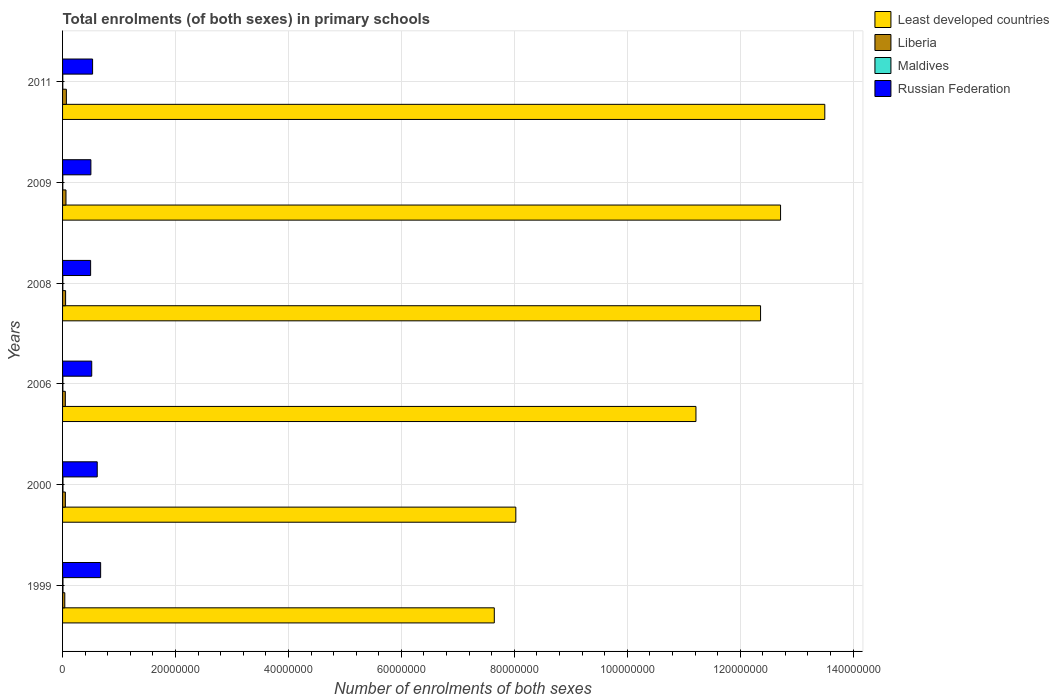How many groups of bars are there?
Your answer should be compact. 6. How many bars are there on the 4th tick from the bottom?
Your response must be concise. 4. What is the label of the 4th group of bars from the top?
Your response must be concise. 2006. What is the number of enrolments in primary schools in Russian Federation in 2000?
Provide a succinct answer. 6.14e+06. Across all years, what is the maximum number of enrolments in primary schools in Liberia?
Offer a terse response. 6.75e+05. Across all years, what is the minimum number of enrolments in primary schools in Liberia?
Your response must be concise. 3.96e+05. In which year was the number of enrolments in primary schools in Maldives minimum?
Offer a terse response. 2011. What is the total number of enrolments in primary schools in Liberia in the graph?
Give a very brief answer. 3.20e+06. What is the difference between the number of enrolments in primary schools in Least developed countries in 2000 and that in 2006?
Your answer should be compact. -3.19e+07. What is the difference between the number of enrolments in primary schools in Liberia in 2009 and the number of enrolments in primary schools in Least developed countries in 2000?
Offer a terse response. -7.97e+07. What is the average number of enrolments in primary schools in Russian Federation per year?
Keep it short and to the point. 5.56e+06. In the year 2008, what is the difference between the number of enrolments in primary schools in Maldives and number of enrolments in primary schools in Russian Federation?
Give a very brief answer. -4.92e+06. What is the ratio of the number of enrolments in primary schools in Liberia in 2000 to that in 2011?
Your answer should be very brief. 0.74. Is the difference between the number of enrolments in primary schools in Maldives in 2006 and 2011 greater than the difference between the number of enrolments in primary schools in Russian Federation in 2006 and 2011?
Provide a short and direct response. Yes. What is the difference between the highest and the second highest number of enrolments in primary schools in Russian Federation?
Your response must be concise. 6.04e+05. What is the difference between the highest and the lowest number of enrolments in primary schools in Least developed countries?
Give a very brief answer. 5.85e+07. Is the sum of the number of enrolments in primary schools in Liberia in 2000 and 2009 greater than the maximum number of enrolments in primary schools in Least developed countries across all years?
Your answer should be compact. No. Is it the case that in every year, the sum of the number of enrolments in primary schools in Maldives and number of enrolments in primary schools in Russian Federation is greater than the sum of number of enrolments in primary schools in Liberia and number of enrolments in primary schools in Least developed countries?
Make the answer very short. No. What does the 1st bar from the top in 2000 represents?
Provide a succinct answer. Russian Federation. What does the 4th bar from the bottom in 1999 represents?
Your answer should be compact. Russian Federation. Is it the case that in every year, the sum of the number of enrolments in primary schools in Least developed countries and number of enrolments in primary schools in Liberia is greater than the number of enrolments in primary schools in Russian Federation?
Offer a very short reply. Yes. How many bars are there?
Offer a very short reply. 24. How many years are there in the graph?
Make the answer very short. 6. Does the graph contain any zero values?
Make the answer very short. No. Where does the legend appear in the graph?
Provide a succinct answer. Top right. How are the legend labels stacked?
Provide a short and direct response. Vertical. What is the title of the graph?
Your response must be concise. Total enrolments (of both sexes) in primary schools. Does "Samoa" appear as one of the legend labels in the graph?
Offer a very short reply. No. What is the label or title of the X-axis?
Provide a short and direct response. Number of enrolments of both sexes. What is the label or title of the Y-axis?
Provide a short and direct response. Years. What is the Number of enrolments of both sexes in Least developed countries in 1999?
Offer a very short reply. 7.65e+07. What is the Number of enrolments of both sexes of Liberia in 1999?
Your answer should be compact. 3.96e+05. What is the Number of enrolments of both sexes in Maldives in 1999?
Provide a succinct answer. 7.40e+04. What is the Number of enrolments of both sexes of Russian Federation in 1999?
Your answer should be very brief. 6.74e+06. What is the Number of enrolments of both sexes in Least developed countries in 2000?
Make the answer very short. 8.03e+07. What is the Number of enrolments of both sexes of Liberia in 2000?
Provide a succinct answer. 4.96e+05. What is the Number of enrolments of both sexes of Maldives in 2000?
Your answer should be very brief. 7.35e+04. What is the Number of enrolments of both sexes of Russian Federation in 2000?
Give a very brief answer. 6.14e+06. What is the Number of enrolments of both sexes in Least developed countries in 2006?
Make the answer very short. 1.12e+08. What is the Number of enrolments of both sexes in Liberia in 2006?
Your response must be concise. 4.88e+05. What is the Number of enrolments of both sexes in Maldives in 2006?
Your response must be concise. 5.48e+04. What is the Number of enrolments of both sexes of Russian Federation in 2006?
Give a very brief answer. 5.16e+06. What is the Number of enrolments of both sexes of Least developed countries in 2008?
Offer a very short reply. 1.24e+08. What is the Number of enrolments of both sexes in Liberia in 2008?
Your answer should be very brief. 5.40e+05. What is the Number of enrolments of both sexes of Maldives in 2008?
Ensure brevity in your answer.  4.71e+04. What is the Number of enrolments of both sexes of Russian Federation in 2008?
Make the answer very short. 4.97e+06. What is the Number of enrolments of both sexes of Least developed countries in 2009?
Provide a short and direct response. 1.27e+08. What is the Number of enrolments of both sexes of Liberia in 2009?
Your answer should be compact. 6.05e+05. What is the Number of enrolments of both sexes of Maldives in 2009?
Your answer should be compact. 4.47e+04. What is the Number of enrolments of both sexes in Russian Federation in 2009?
Provide a succinct answer. 5.02e+06. What is the Number of enrolments of both sexes of Least developed countries in 2011?
Provide a succinct answer. 1.35e+08. What is the Number of enrolments of both sexes of Liberia in 2011?
Provide a short and direct response. 6.75e+05. What is the Number of enrolments of both sexes in Maldives in 2011?
Your answer should be very brief. 4.02e+04. What is the Number of enrolments of both sexes of Russian Federation in 2011?
Provide a short and direct response. 5.32e+06. Across all years, what is the maximum Number of enrolments of both sexes in Least developed countries?
Keep it short and to the point. 1.35e+08. Across all years, what is the maximum Number of enrolments of both sexes of Liberia?
Make the answer very short. 6.75e+05. Across all years, what is the maximum Number of enrolments of both sexes in Maldives?
Offer a very short reply. 7.40e+04. Across all years, what is the maximum Number of enrolments of both sexes in Russian Federation?
Provide a succinct answer. 6.74e+06. Across all years, what is the minimum Number of enrolments of both sexes in Least developed countries?
Your response must be concise. 7.65e+07. Across all years, what is the minimum Number of enrolments of both sexes of Liberia?
Keep it short and to the point. 3.96e+05. Across all years, what is the minimum Number of enrolments of both sexes of Maldives?
Offer a very short reply. 4.02e+04. Across all years, what is the minimum Number of enrolments of both sexes of Russian Federation?
Offer a terse response. 4.97e+06. What is the total Number of enrolments of both sexes of Least developed countries in the graph?
Offer a very short reply. 6.55e+08. What is the total Number of enrolments of both sexes in Liberia in the graph?
Offer a very short reply. 3.20e+06. What is the total Number of enrolments of both sexes of Maldives in the graph?
Offer a terse response. 3.34e+05. What is the total Number of enrolments of both sexes of Russian Federation in the graph?
Provide a short and direct response. 3.33e+07. What is the difference between the Number of enrolments of both sexes of Least developed countries in 1999 and that in 2000?
Provide a short and direct response. -3.81e+06. What is the difference between the Number of enrolments of both sexes in Liberia in 1999 and that in 2000?
Your response must be concise. -1.01e+05. What is the difference between the Number of enrolments of both sexes in Maldives in 1999 and that in 2000?
Your answer should be compact. 528. What is the difference between the Number of enrolments of both sexes in Russian Federation in 1999 and that in 2000?
Keep it short and to the point. 6.04e+05. What is the difference between the Number of enrolments of both sexes of Least developed countries in 1999 and that in 2006?
Provide a succinct answer. -3.57e+07. What is the difference between the Number of enrolments of both sexes of Liberia in 1999 and that in 2006?
Your response must be concise. -9.28e+04. What is the difference between the Number of enrolments of both sexes of Maldives in 1999 and that in 2006?
Your response must be concise. 1.93e+04. What is the difference between the Number of enrolments of both sexes of Russian Federation in 1999 and that in 2006?
Your response must be concise. 1.58e+06. What is the difference between the Number of enrolments of both sexes of Least developed countries in 1999 and that in 2008?
Your response must be concise. -4.72e+07. What is the difference between the Number of enrolments of both sexes of Liberia in 1999 and that in 2008?
Your answer should be compact. -1.44e+05. What is the difference between the Number of enrolments of both sexes of Maldives in 1999 and that in 2008?
Keep it short and to the point. 2.70e+04. What is the difference between the Number of enrolments of both sexes of Russian Federation in 1999 and that in 2008?
Provide a succinct answer. 1.77e+06. What is the difference between the Number of enrolments of both sexes in Least developed countries in 1999 and that in 2009?
Your answer should be compact. -5.07e+07. What is the difference between the Number of enrolments of both sexes in Liberia in 1999 and that in 2009?
Offer a very short reply. -2.10e+05. What is the difference between the Number of enrolments of both sexes in Maldives in 1999 and that in 2009?
Your answer should be very brief. 2.94e+04. What is the difference between the Number of enrolments of both sexes of Russian Federation in 1999 and that in 2009?
Your response must be concise. 1.73e+06. What is the difference between the Number of enrolments of both sexes in Least developed countries in 1999 and that in 2011?
Offer a very short reply. -5.85e+07. What is the difference between the Number of enrolments of both sexes in Liberia in 1999 and that in 2011?
Offer a very short reply. -2.79e+05. What is the difference between the Number of enrolments of both sexes of Maldives in 1999 and that in 2011?
Ensure brevity in your answer.  3.38e+04. What is the difference between the Number of enrolments of both sexes of Russian Federation in 1999 and that in 2011?
Offer a very short reply. 1.42e+06. What is the difference between the Number of enrolments of both sexes of Least developed countries in 2000 and that in 2006?
Your response must be concise. -3.19e+07. What is the difference between the Number of enrolments of both sexes of Liberia in 2000 and that in 2006?
Your answer should be very brief. 7815. What is the difference between the Number of enrolments of both sexes in Maldives in 2000 and that in 2006?
Give a very brief answer. 1.88e+04. What is the difference between the Number of enrolments of both sexes in Russian Federation in 2000 and that in 2006?
Your response must be concise. 9.74e+05. What is the difference between the Number of enrolments of both sexes in Least developed countries in 2000 and that in 2008?
Your answer should be compact. -4.33e+07. What is the difference between the Number of enrolments of both sexes in Liberia in 2000 and that in 2008?
Your answer should be very brief. -4.36e+04. What is the difference between the Number of enrolments of both sexes of Maldives in 2000 and that in 2008?
Offer a very short reply. 2.64e+04. What is the difference between the Number of enrolments of both sexes in Russian Federation in 2000 and that in 2008?
Provide a short and direct response. 1.17e+06. What is the difference between the Number of enrolments of both sexes in Least developed countries in 2000 and that in 2009?
Ensure brevity in your answer.  -4.69e+07. What is the difference between the Number of enrolments of both sexes in Liberia in 2000 and that in 2009?
Keep it short and to the point. -1.09e+05. What is the difference between the Number of enrolments of both sexes in Maldives in 2000 and that in 2009?
Give a very brief answer. 2.88e+04. What is the difference between the Number of enrolments of both sexes of Russian Federation in 2000 and that in 2009?
Give a very brief answer. 1.12e+06. What is the difference between the Number of enrolments of both sexes in Least developed countries in 2000 and that in 2011?
Ensure brevity in your answer.  -5.47e+07. What is the difference between the Number of enrolments of both sexes in Liberia in 2000 and that in 2011?
Provide a succinct answer. -1.78e+05. What is the difference between the Number of enrolments of both sexes of Maldives in 2000 and that in 2011?
Ensure brevity in your answer.  3.33e+04. What is the difference between the Number of enrolments of both sexes in Russian Federation in 2000 and that in 2011?
Offer a very short reply. 8.20e+05. What is the difference between the Number of enrolments of both sexes of Least developed countries in 2006 and that in 2008?
Your answer should be compact. -1.14e+07. What is the difference between the Number of enrolments of both sexes in Liberia in 2006 and that in 2008?
Offer a terse response. -5.14e+04. What is the difference between the Number of enrolments of both sexes of Maldives in 2006 and that in 2008?
Offer a very short reply. 7688. What is the difference between the Number of enrolments of both sexes of Russian Federation in 2006 and that in 2008?
Provide a short and direct response. 1.96e+05. What is the difference between the Number of enrolments of both sexes in Least developed countries in 2006 and that in 2009?
Provide a short and direct response. -1.50e+07. What is the difference between the Number of enrolments of both sexes in Liberia in 2006 and that in 2009?
Provide a short and direct response. -1.17e+05. What is the difference between the Number of enrolments of both sexes in Maldives in 2006 and that in 2009?
Offer a terse response. 1.01e+04. What is the difference between the Number of enrolments of both sexes of Russian Federation in 2006 and that in 2009?
Keep it short and to the point. 1.49e+05. What is the difference between the Number of enrolments of both sexes of Least developed countries in 2006 and that in 2011?
Your answer should be very brief. -2.28e+07. What is the difference between the Number of enrolments of both sexes in Liberia in 2006 and that in 2011?
Your answer should be compact. -1.86e+05. What is the difference between the Number of enrolments of both sexes in Maldives in 2006 and that in 2011?
Make the answer very short. 1.46e+04. What is the difference between the Number of enrolments of both sexes in Russian Federation in 2006 and that in 2011?
Make the answer very short. -1.54e+05. What is the difference between the Number of enrolments of both sexes of Least developed countries in 2008 and that in 2009?
Make the answer very short. -3.54e+06. What is the difference between the Number of enrolments of both sexes in Liberia in 2008 and that in 2009?
Provide a succinct answer. -6.53e+04. What is the difference between the Number of enrolments of both sexes in Maldives in 2008 and that in 2009?
Offer a terse response. 2407. What is the difference between the Number of enrolments of both sexes of Russian Federation in 2008 and that in 2009?
Offer a very short reply. -4.66e+04. What is the difference between the Number of enrolments of both sexes of Least developed countries in 2008 and that in 2011?
Offer a very short reply. -1.14e+07. What is the difference between the Number of enrolments of both sexes of Liberia in 2008 and that in 2011?
Your answer should be compact. -1.35e+05. What is the difference between the Number of enrolments of both sexes in Maldives in 2008 and that in 2011?
Provide a succinct answer. 6881. What is the difference between the Number of enrolments of both sexes of Russian Federation in 2008 and that in 2011?
Offer a terse response. -3.50e+05. What is the difference between the Number of enrolments of both sexes of Least developed countries in 2009 and that in 2011?
Keep it short and to the point. -7.83e+06. What is the difference between the Number of enrolments of both sexes in Liberia in 2009 and that in 2011?
Give a very brief answer. -6.93e+04. What is the difference between the Number of enrolments of both sexes in Maldives in 2009 and that in 2011?
Give a very brief answer. 4474. What is the difference between the Number of enrolments of both sexes in Russian Federation in 2009 and that in 2011?
Your response must be concise. -3.03e+05. What is the difference between the Number of enrolments of both sexes in Least developed countries in 1999 and the Number of enrolments of both sexes in Liberia in 2000?
Offer a very short reply. 7.60e+07. What is the difference between the Number of enrolments of both sexes in Least developed countries in 1999 and the Number of enrolments of both sexes in Maldives in 2000?
Keep it short and to the point. 7.64e+07. What is the difference between the Number of enrolments of both sexes of Least developed countries in 1999 and the Number of enrolments of both sexes of Russian Federation in 2000?
Offer a terse response. 7.03e+07. What is the difference between the Number of enrolments of both sexes in Liberia in 1999 and the Number of enrolments of both sexes in Maldives in 2000?
Ensure brevity in your answer.  3.22e+05. What is the difference between the Number of enrolments of both sexes in Liberia in 1999 and the Number of enrolments of both sexes in Russian Federation in 2000?
Offer a very short reply. -5.74e+06. What is the difference between the Number of enrolments of both sexes of Maldives in 1999 and the Number of enrolments of both sexes of Russian Federation in 2000?
Offer a terse response. -6.06e+06. What is the difference between the Number of enrolments of both sexes in Least developed countries in 1999 and the Number of enrolments of both sexes in Liberia in 2006?
Provide a succinct answer. 7.60e+07. What is the difference between the Number of enrolments of both sexes of Least developed countries in 1999 and the Number of enrolments of both sexes of Maldives in 2006?
Provide a succinct answer. 7.64e+07. What is the difference between the Number of enrolments of both sexes in Least developed countries in 1999 and the Number of enrolments of both sexes in Russian Federation in 2006?
Provide a short and direct response. 7.13e+07. What is the difference between the Number of enrolments of both sexes in Liberia in 1999 and the Number of enrolments of both sexes in Maldives in 2006?
Give a very brief answer. 3.41e+05. What is the difference between the Number of enrolments of both sexes of Liberia in 1999 and the Number of enrolments of both sexes of Russian Federation in 2006?
Make the answer very short. -4.77e+06. What is the difference between the Number of enrolments of both sexes of Maldives in 1999 and the Number of enrolments of both sexes of Russian Federation in 2006?
Your answer should be compact. -5.09e+06. What is the difference between the Number of enrolments of both sexes in Least developed countries in 1999 and the Number of enrolments of both sexes in Liberia in 2008?
Offer a terse response. 7.59e+07. What is the difference between the Number of enrolments of both sexes in Least developed countries in 1999 and the Number of enrolments of both sexes in Maldives in 2008?
Your response must be concise. 7.64e+07. What is the difference between the Number of enrolments of both sexes of Least developed countries in 1999 and the Number of enrolments of both sexes of Russian Federation in 2008?
Offer a very short reply. 7.15e+07. What is the difference between the Number of enrolments of both sexes of Liberia in 1999 and the Number of enrolments of both sexes of Maldives in 2008?
Offer a very short reply. 3.49e+05. What is the difference between the Number of enrolments of both sexes of Liberia in 1999 and the Number of enrolments of both sexes of Russian Federation in 2008?
Provide a short and direct response. -4.57e+06. What is the difference between the Number of enrolments of both sexes in Maldives in 1999 and the Number of enrolments of both sexes in Russian Federation in 2008?
Your answer should be compact. -4.89e+06. What is the difference between the Number of enrolments of both sexes in Least developed countries in 1999 and the Number of enrolments of both sexes in Liberia in 2009?
Ensure brevity in your answer.  7.58e+07. What is the difference between the Number of enrolments of both sexes of Least developed countries in 1999 and the Number of enrolments of both sexes of Maldives in 2009?
Provide a short and direct response. 7.64e+07. What is the difference between the Number of enrolments of both sexes of Least developed countries in 1999 and the Number of enrolments of both sexes of Russian Federation in 2009?
Offer a terse response. 7.14e+07. What is the difference between the Number of enrolments of both sexes in Liberia in 1999 and the Number of enrolments of both sexes in Maldives in 2009?
Provide a succinct answer. 3.51e+05. What is the difference between the Number of enrolments of both sexes of Liberia in 1999 and the Number of enrolments of both sexes of Russian Federation in 2009?
Provide a short and direct response. -4.62e+06. What is the difference between the Number of enrolments of both sexes of Maldives in 1999 and the Number of enrolments of both sexes of Russian Federation in 2009?
Ensure brevity in your answer.  -4.94e+06. What is the difference between the Number of enrolments of both sexes of Least developed countries in 1999 and the Number of enrolments of both sexes of Liberia in 2011?
Provide a short and direct response. 7.58e+07. What is the difference between the Number of enrolments of both sexes of Least developed countries in 1999 and the Number of enrolments of both sexes of Maldives in 2011?
Offer a very short reply. 7.64e+07. What is the difference between the Number of enrolments of both sexes of Least developed countries in 1999 and the Number of enrolments of both sexes of Russian Federation in 2011?
Give a very brief answer. 7.11e+07. What is the difference between the Number of enrolments of both sexes of Liberia in 1999 and the Number of enrolments of both sexes of Maldives in 2011?
Make the answer very short. 3.55e+05. What is the difference between the Number of enrolments of both sexes in Liberia in 1999 and the Number of enrolments of both sexes in Russian Federation in 2011?
Your answer should be compact. -4.92e+06. What is the difference between the Number of enrolments of both sexes of Maldives in 1999 and the Number of enrolments of both sexes of Russian Federation in 2011?
Keep it short and to the point. -5.24e+06. What is the difference between the Number of enrolments of both sexes in Least developed countries in 2000 and the Number of enrolments of both sexes in Liberia in 2006?
Provide a short and direct response. 7.98e+07. What is the difference between the Number of enrolments of both sexes of Least developed countries in 2000 and the Number of enrolments of both sexes of Maldives in 2006?
Give a very brief answer. 8.02e+07. What is the difference between the Number of enrolments of both sexes in Least developed countries in 2000 and the Number of enrolments of both sexes in Russian Federation in 2006?
Make the answer very short. 7.51e+07. What is the difference between the Number of enrolments of both sexes of Liberia in 2000 and the Number of enrolments of both sexes of Maldives in 2006?
Provide a succinct answer. 4.41e+05. What is the difference between the Number of enrolments of both sexes of Liberia in 2000 and the Number of enrolments of both sexes of Russian Federation in 2006?
Offer a very short reply. -4.67e+06. What is the difference between the Number of enrolments of both sexes of Maldives in 2000 and the Number of enrolments of both sexes of Russian Federation in 2006?
Provide a short and direct response. -5.09e+06. What is the difference between the Number of enrolments of both sexes of Least developed countries in 2000 and the Number of enrolments of both sexes of Liberia in 2008?
Keep it short and to the point. 7.97e+07. What is the difference between the Number of enrolments of both sexes in Least developed countries in 2000 and the Number of enrolments of both sexes in Maldives in 2008?
Your answer should be compact. 8.02e+07. What is the difference between the Number of enrolments of both sexes of Least developed countries in 2000 and the Number of enrolments of both sexes of Russian Federation in 2008?
Offer a terse response. 7.53e+07. What is the difference between the Number of enrolments of both sexes of Liberia in 2000 and the Number of enrolments of both sexes of Maldives in 2008?
Ensure brevity in your answer.  4.49e+05. What is the difference between the Number of enrolments of both sexes in Liberia in 2000 and the Number of enrolments of both sexes in Russian Federation in 2008?
Your response must be concise. -4.47e+06. What is the difference between the Number of enrolments of both sexes in Maldives in 2000 and the Number of enrolments of both sexes in Russian Federation in 2008?
Make the answer very short. -4.90e+06. What is the difference between the Number of enrolments of both sexes in Least developed countries in 2000 and the Number of enrolments of both sexes in Liberia in 2009?
Make the answer very short. 7.97e+07. What is the difference between the Number of enrolments of both sexes of Least developed countries in 2000 and the Number of enrolments of both sexes of Maldives in 2009?
Ensure brevity in your answer.  8.02e+07. What is the difference between the Number of enrolments of both sexes in Least developed countries in 2000 and the Number of enrolments of both sexes in Russian Federation in 2009?
Offer a very short reply. 7.52e+07. What is the difference between the Number of enrolments of both sexes in Liberia in 2000 and the Number of enrolments of both sexes in Maldives in 2009?
Keep it short and to the point. 4.52e+05. What is the difference between the Number of enrolments of both sexes of Liberia in 2000 and the Number of enrolments of both sexes of Russian Federation in 2009?
Provide a succinct answer. -4.52e+06. What is the difference between the Number of enrolments of both sexes of Maldives in 2000 and the Number of enrolments of both sexes of Russian Federation in 2009?
Your answer should be very brief. -4.94e+06. What is the difference between the Number of enrolments of both sexes in Least developed countries in 2000 and the Number of enrolments of both sexes in Liberia in 2011?
Provide a short and direct response. 7.96e+07. What is the difference between the Number of enrolments of both sexes of Least developed countries in 2000 and the Number of enrolments of both sexes of Maldives in 2011?
Make the answer very short. 8.02e+07. What is the difference between the Number of enrolments of both sexes of Least developed countries in 2000 and the Number of enrolments of both sexes of Russian Federation in 2011?
Make the answer very short. 7.49e+07. What is the difference between the Number of enrolments of both sexes in Liberia in 2000 and the Number of enrolments of both sexes in Maldives in 2011?
Give a very brief answer. 4.56e+05. What is the difference between the Number of enrolments of both sexes in Liberia in 2000 and the Number of enrolments of both sexes in Russian Federation in 2011?
Your answer should be very brief. -4.82e+06. What is the difference between the Number of enrolments of both sexes of Maldives in 2000 and the Number of enrolments of both sexes of Russian Federation in 2011?
Offer a very short reply. -5.24e+06. What is the difference between the Number of enrolments of both sexes of Least developed countries in 2006 and the Number of enrolments of both sexes of Liberia in 2008?
Your response must be concise. 1.12e+08. What is the difference between the Number of enrolments of both sexes of Least developed countries in 2006 and the Number of enrolments of both sexes of Maldives in 2008?
Keep it short and to the point. 1.12e+08. What is the difference between the Number of enrolments of both sexes of Least developed countries in 2006 and the Number of enrolments of both sexes of Russian Federation in 2008?
Give a very brief answer. 1.07e+08. What is the difference between the Number of enrolments of both sexes of Liberia in 2006 and the Number of enrolments of both sexes of Maldives in 2008?
Your answer should be compact. 4.41e+05. What is the difference between the Number of enrolments of both sexes of Liberia in 2006 and the Number of enrolments of both sexes of Russian Federation in 2008?
Your answer should be very brief. -4.48e+06. What is the difference between the Number of enrolments of both sexes in Maldives in 2006 and the Number of enrolments of both sexes in Russian Federation in 2008?
Ensure brevity in your answer.  -4.91e+06. What is the difference between the Number of enrolments of both sexes in Least developed countries in 2006 and the Number of enrolments of both sexes in Liberia in 2009?
Your answer should be very brief. 1.12e+08. What is the difference between the Number of enrolments of both sexes of Least developed countries in 2006 and the Number of enrolments of both sexes of Maldives in 2009?
Give a very brief answer. 1.12e+08. What is the difference between the Number of enrolments of both sexes in Least developed countries in 2006 and the Number of enrolments of both sexes in Russian Federation in 2009?
Your answer should be very brief. 1.07e+08. What is the difference between the Number of enrolments of both sexes in Liberia in 2006 and the Number of enrolments of both sexes in Maldives in 2009?
Offer a terse response. 4.44e+05. What is the difference between the Number of enrolments of both sexes of Liberia in 2006 and the Number of enrolments of both sexes of Russian Federation in 2009?
Provide a succinct answer. -4.53e+06. What is the difference between the Number of enrolments of both sexes of Maldives in 2006 and the Number of enrolments of both sexes of Russian Federation in 2009?
Give a very brief answer. -4.96e+06. What is the difference between the Number of enrolments of both sexes of Least developed countries in 2006 and the Number of enrolments of both sexes of Liberia in 2011?
Offer a very short reply. 1.11e+08. What is the difference between the Number of enrolments of both sexes in Least developed countries in 2006 and the Number of enrolments of both sexes in Maldives in 2011?
Give a very brief answer. 1.12e+08. What is the difference between the Number of enrolments of both sexes in Least developed countries in 2006 and the Number of enrolments of both sexes in Russian Federation in 2011?
Make the answer very short. 1.07e+08. What is the difference between the Number of enrolments of both sexes in Liberia in 2006 and the Number of enrolments of both sexes in Maldives in 2011?
Make the answer very short. 4.48e+05. What is the difference between the Number of enrolments of both sexes in Liberia in 2006 and the Number of enrolments of both sexes in Russian Federation in 2011?
Make the answer very short. -4.83e+06. What is the difference between the Number of enrolments of both sexes of Maldives in 2006 and the Number of enrolments of both sexes of Russian Federation in 2011?
Provide a short and direct response. -5.26e+06. What is the difference between the Number of enrolments of both sexes of Least developed countries in 2008 and the Number of enrolments of both sexes of Liberia in 2009?
Ensure brevity in your answer.  1.23e+08. What is the difference between the Number of enrolments of both sexes of Least developed countries in 2008 and the Number of enrolments of both sexes of Maldives in 2009?
Keep it short and to the point. 1.24e+08. What is the difference between the Number of enrolments of both sexes of Least developed countries in 2008 and the Number of enrolments of both sexes of Russian Federation in 2009?
Offer a very short reply. 1.19e+08. What is the difference between the Number of enrolments of both sexes in Liberia in 2008 and the Number of enrolments of both sexes in Maldives in 2009?
Keep it short and to the point. 4.95e+05. What is the difference between the Number of enrolments of both sexes of Liberia in 2008 and the Number of enrolments of both sexes of Russian Federation in 2009?
Ensure brevity in your answer.  -4.48e+06. What is the difference between the Number of enrolments of both sexes in Maldives in 2008 and the Number of enrolments of both sexes in Russian Federation in 2009?
Ensure brevity in your answer.  -4.97e+06. What is the difference between the Number of enrolments of both sexes in Least developed countries in 2008 and the Number of enrolments of both sexes in Liberia in 2011?
Provide a short and direct response. 1.23e+08. What is the difference between the Number of enrolments of both sexes in Least developed countries in 2008 and the Number of enrolments of both sexes in Maldives in 2011?
Provide a short and direct response. 1.24e+08. What is the difference between the Number of enrolments of both sexes of Least developed countries in 2008 and the Number of enrolments of both sexes of Russian Federation in 2011?
Your answer should be very brief. 1.18e+08. What is the difference between the Number of enrolments of both sexes of Liberia in 2008 and the Number of enrolments of both sexes of Maldives in 2011?
Offer a very short reply. 5.00e+05. What is the difference between the Number of enrolments of both sexes of Liberia in 2008 and the Number of enrolments of both sexes of Russian Federation in 2011?
Provide a short and direct response. -4.78e+06. What is the difference between the Number of enrolments of both sexes of Maldives in 2008 and the Number of enrolments of both sexes of Russian Federation in 2011?
Provide a short and direct response. -5.27e+06. What is the difference between the Number of enrolments of both sexes in Least developed countries in 2009 and the Number of enrolments of both sexes in Liberia in 2011?
Provide a succinct answer. 1.26e+08. What is the difference between the Number of enrolments of both sexes of Least developed countries in 2009 and the Number of enrolments of both sexes of Maldives in 2011?
Your answer should be compact. 1.27e+08. What is the difference between the Number of enrolments of both sexes in Least developed countries in 2009 and the Number of enrolments of both sexes in Russian Federation in 2011?
Ensure brevity in your answer.  1.22e+08. What is the difference between the Number of enrolments of both sexes of Liberia in 2009 and the Number of enrolments of both sexes of Maldives in 2011?
Ensure brevity in your answer.  5.65e+05. What is the difference between the Number of enrolments of both sexes of Liberia in 2009 and the Number of enrolments of both sexes of Russian Federation in 2011?
Offer a very short reply. -4.71e+06. What is the difference between the Number of enrolments of both sexes of Maldives in 2009 and the Number of enrolments of both sexes of Russian Federation in 2011?
Provide a succinct answer. -5.27e+06. What is the average Number of enrolments of both sexes in Least developed countries per year?
Offer a terse response. 1.09e+08. What is the average Number of enrolments of both sexes in Liberia per year?
Provide a succinct answer. 5.33e+05. What is the average Number of enrolments of both sexes of Maldives per year?
Provide a short and direct response. 5.57e+04. What is the average Number of enrolments of both sexes of Russian Federation per year?
Keep it short and to the point. 5.56e+06. In the year 1999, what is the difference between the Number of enrolments of both sexes of Least developed countries and Number of enrolments of both sexes of Liberia?
Your answer should be compact. 7.61e+07. In the year 1999, what is the difference between the Number of enrolments of both sexes in Least developed countries and Number of enrolments of both sexes in Maldives?
Your response must be concise. 7.64e+07. In the year 1999, what is the difference between the Number of enrolments of both sexes of Least developed countries and Number of enrolments of both sexes of Russian Federation?
Your answer should be compact. 6.97e+07. In the year 1999, what is the difference between the Number of enrolments of both sexes in Liberia and Number of enrolments of both sexes in Maldives?
Give a very brief answer. 3.22e+05. In the year 1999, what is the difference between the Number of enrolments of both sexes in Liberia and Number of enrolments of both sexes in Russian Federation?
Offer a very short reply. -6.35e+06. In the year 1999, what is the difference between the Number of enrolments of both sexes of Maldives and Number of enrolments of both sexes of Russian Federation?
Give a very brief answer. -6.67e+06. In the year 2000, what is the difference between the Number of enrolments of both sexes in Least developed countries and Number of enrolments of both sexes in Liberia?
Offer a terse response. 7.98e+07. In the year 2000, what is the difference between the Number of enrolments of both sexes of Least developed countries and Number of enrolments of both sexes of Maldives?
Your answer should be compact. 8.02e+07. In the year 2000, what is the difference between the Number of enrolments of both sexes in Least developed countries and Number of enrolments of both sexes in Russian Federation?
Offer a very short reply. 7.41e+07. In the year 2000, what is the difference between the Number of enrolments of both sexes of Liberia and Number of enrolments of both sexes of Maldives?
Provide a succinct answer. 4.23e+05. In the year 2000, what is the difference between the Number of enrolments of both sexes in Liberia and Number of enrolments of both sexes in Russian Federation?
Provide a succinct answer. -5.64e+06. In the year 2000, what is the difference between the Number of enrolments of both sexes in Maldives and Number of enrolments of both sexes in Russian Federation?
Ensure brevity in your answer.  -6.06e+06. In the year 2006, what is the difference between the Number of enrolments of both sexes in Least developed countries and Number of enrolments of both sexes in Liberia?
Make the answer very short. 1.12e+08. In the year 2006, what is the difference between the Number of enrolments of both sexes of Least developed countries and Number of enrolments of both sexes of Maldives?
Provide a succinct answer. 1.12e+08. In the year 2006, what is the difference between the Number of enrolments of both sexes of Least developed countries and Number of enrolments of both sexes of Russian Federation?
Provide a short and direct response. 1.07e+08. In the year 2006, what is the difference between the Number of enrolments of both sexes in Liberia and Number of enrolments of both sexes in Maldives?
Provide a succinct answer. 4.34e+05. In the year 2006, what is the difference between the Number of enrolments of both sexes of Liberia and Number of enrolments of both sexes of Russian Federation?
Keep it short and to the point. -4.68e+06. In the year 2006, what is the difference between the Number of enrolments of both sexes in Maldives and Number of enrolments of both sexes in Russian Federation?
Make the answer very short. -5.11e+06. In the year 2008, what is the difference between the Number of enrolments of both sexes of Least developed countries and Number of enrolments of both sexes of Liberia?
Offer a terse response. 1.23e+08. In the year 2008, what is the difference between the Number of enrolments of both sexes of Least developed countries and Number of enrolments of both sexes of Maldives?
Your answer should be compact. 1.24e+08. In the year 2008, what is the difference between the Number of enrolments of both sexes of Least developed countries and Number of enrolments of both sexes of Russian Federation?
Offer a terse response. 1.19e+08. In the year 2008, what is the difference between the Number of enrolments of both sexes of Liberia and Number of enrolments of both sexes of Maldives?
Ensure brevity in your answer.  4.93e+05. In the year 2008, what is the difference between the Number of enrolments of both sexes in Liberia and Number of enrolments of both sexes in Russian Federation?
Make the answer very short. -4.43e+06. In the year 2008, what is the difference between the Number of enrolments of both sexes in Maldives and Number of enrolments of both sexes in Russian Federation?
Your response must be concise. -4.92e+06. In the year 2009, what is the difference between the Number of enrolments of both sexes in Least developed countries and Number of enrolments of both sexes in Liberia?
Your answer should be very brief. 1.27e+08. In the year 2009, what is the difference between the Number of enrolments of both sexes of Least developed countries and Number of enrolments of both sexes of Maldives?
Your response must be concise. 1.27e+08. In the year 2009, what is the difference between the Number of enrolments of both sexes of Least developed countries and Number of enrolments of both sexes of Russian Federation?
Offer a very short reply. 1.22e+08. In the year 2009, what is the difference between the Number of enrolments of both sexes of Liberia and Number of enrolments of both sexes of Maldives?
Ensure brevity in your answer.  5.61e+05. In the year 2009, what is the difference between the Number of enrolments of both sexes of Liberia and Number of enrolments of both sexes of Russian Federation?
Your answer should be very brief. -4.41e+06. In the year 2009, what is the difference between the Number of enrolments of both sexes in Maldives and Number of enrolments of both sexes in Russian Federation?
Provide a short and direct response. -4.97e+06. In the year 2011, what is the difference between the Number of enrolments of both sexes in Least developed countries and Number of enrolments of both sexes in Liberia?
Give a very brief answer. 1.34e+08. In the year 2011, what is the difference between the Number of enrolments of both sexes of Least developed countries and Number of enrolments of both sexes of Maldives?
Offer a very short reply. 1.35e+08. In the year 2011, what is the difference between the Number of enrolments of both sexes of Least developed countries and Number of enrolments of both sexes of Russian Federation?
Give a very brief answer. 1.30e+08. In the year 2011, what is the difference between the Number of enrolments of both sexes of Liberia and Number of enrolments of both sexes of Maldives?
Ensure brevity in your answer.  6.34e+05. In the year 2011, what is the difference between the Number of enrolments of both sexes in Liberia and Number of enrolments of both sexes in Russian Federation?
Keep it short and to the point. -4.64e+06. In the year 2011, what is the difference between the Number of enrolments of both sexes in Maldives and Number of enrolments of both sexes in Russian Federation?
Make the answer very short. -5.28e+06. What is the ratio of the Number of enrolments of both sexes of Least developed countries in 1999 to that in 2000?
Keep it short and to the point. 0.95. What is the ratio of the Number of enrolments of both sexes of Liberia in 1999 to that in 2000?
Your answer should be very brief. 0.8. What is the ratio of the Number of enrolments of both sexes in Russian Federation in 1999 to that in 2000?
Your response must be concise. 1.1. What is the ratio of the Number of enrolments of both sexes of Least developed countries in 1999 to that in 2006?
Your answer should be very brief. 0.68. What is the ratio of the Number of enrolments of both sexes of Liberia in 1999 to that in 2006?
Offer a terse response. 0.81. What is the ratio of the Number of enrolments of both sexes in Maldives in 1999 to that in 2006?
Ensure brevity in your answer.  1.35. What is the ratio of the Number of enrolments of both sexes in Russian Federation in 1999 to that in 2006?
Keep it short and to the point. 1.31. What is the ratio of the Number of enrolments of both sexes in Least developed countries in 1999 to that in 2008?
Give a very brief answer. 0.62. What is the ratio of the Number of enrolments of both sexes of Liberia in 1999 to that in 2008?
Your answer should be very brief. 0.73. What is the ratio of the Number of enrolments of both sexes in Maldives in 1999 to that in 2008?
Offer a terse response. 1.57. What is the ratio of the Number of enrolments of both sexes of Russian Federation in 1999 to that in 2008?
Your answer should be very brief. 1.36. What is the ratio of the Number of enrolments of both sexes in Least developed countries in 1999 to that in 2009?
Give a very brief answer. 0.6. What is the ratio of the Number of enrolments of both sexes of Liberia in 1999 to that in 2009?
Provide a succinct answer. 0.65. What is the ratio of the Number of enrolments of both sexes in Maldives in 1999 to that in 2009?
Keep it short and to the point. 1.66. What is the ratio of the Number of enrolments of both sexes in Russian Federation in 1999 to that in 2009?
Your answer should be very brief. 1.34. What is the ratio of the Number of enrolments of both sexes of Least developed countries in 1999 to that in 2011?
Offer a very short reply. 0.57. What is the ratio of the Number of enrolments of both sexes of Liberia in 1999 to that in 2011?
Your answer should be compact. 0.59. What is the ratio of the Number of enrolments of both sexes of Maldives in 1999 to that in 2011?
Keep it short and to the point. 1.84. What is the ratio of the Number of enrolments of both sexes of Russian Federation in 1999 to that in 2011?
Provide a short and direct response. 1.27. What is the ratio of the Number of enrolments of both sexes in Least developed countries in 2000 to that in 2006?
Your answer should be very brief. 0.72. What is the ratio of the Number of enrolments of both sexes of Maldives in 2000 to that in 2006?
Offer a terse response. 1.34. What is the ratio of the Number of enrolments of both sexes of Russian Federation in 2000 to that in 2006?
Give a very brief answer. 1.19. What is the ratio of the Number of enrolments of both sexes of Least developed countries in 2000 to that in 2008?
Ensure brevity in your answer.  0.65. What is the ratio of the Number of enrolments of both sexes of Liberia in 2000 to that in 2008?
Provide a short and direct response. 0.92. What is the ratio of the Number of enrolments of both sexes of Maldives in 2000 to that in 2008?
Your answer should be very brief. 1.56. What is the ratio of the Number of enrolments of both sexes of Russian Federation in 2000 to that in 2008?
Your answer should be compact. 1.24. What is the ratio of the Number of enrolments of both sexes of Least developed countries in 2000 to that in 2009?
Your answer should be very brief. 0.63. What is the ratio of the Number of enrolments of both sexes of Liberia in 2000 to that in 2009?
Your answer should be compact. 0.82. What is the ratio of the Number of enrolments of both sexes in Maldives in 2000 to that in 2009?
Make the answer very short. 1.65. What is the ratio of the Number of enrolments of both sexes in Russian Federation in 2000 to that in 2009?
Your answer should be compact. 1.22. What is the ratio of the Number of enrolments of both sexes of Least developed countries in 2000 to that in 2011?
Provide a short and direct response. 0.59. What is the ratio of the Number of enrolments of both sexes of Liberia in 2000 to that in 2011?
Your answer should be compact. 0.74. What is the ratio of the Number of enrolments of both sexes in Maldives in 2000 to that in 2011?
Your answer should be very brief. 1.83. What is the ratio of the Number of enrolments of both sexes in Russian Federation in 2000 to that in 2011?
Offer a terse response. 1.15. What is the ratio of the Number of enrolments of both sexes of Least developed countries in 2006 to that in 2008?
Give a very brief answer. 0.91. What is the ratio of the Number of enrolments of both sexes of Liberia in 2006 to that in 2008?
Make the answer very short. 0.9. What is the ratio of the Number of enrolments of both sexes of Maldives in 2006 to that in 2008?
Provide a succinct answer. 1.16. What is the ratio of the Number of enrolments of both sexes of Russian Federation in 2006 to that in 2008?
Your answer should be compact. 1.04. What is the ratio of the Number of enrolments of both sexes of Least developed countries in 2006 to that in 2009?
Keep it short and to the point. 0.88. What is the ratio of the Number of enrolments of both sexes in Liberia in 2006 to that in 2009?
Your response must be concise. 0.81. What is the ratio of the Number of enrolments of both sexes of Maldives in 2006 to that in 2009?
Your answer should be very brief. 1.23. What is the ratio of the Number of enrolments of both sexes in Russian Federation in 2006 to that in 2009?
Ensure brevity in your answer.  1.03. What is the ratio of the Number of enrolments of both sexes in Least developed countries in 2006 to that in 2011?
Provide a succinct answer. 0.83. What is the ratio of the Number of enrolments of both sexes in Liberia in 2006 to that in 2011?
Your response must be concise. 0.72. What is the ratio of the Number of enrolments of both sexes of Maldives in 2006 to that in 2011?
Keep it short and to the point. 1.36. What is the ratio of the Number of enrolments of both sexes of Russian Federation in 2006 to that in 2011?
Offer a very short reply. 0.97. What is the ratio of the Number of enrolments of both sexes of Least developed countries in 2008 to that in 2009?
Provide a succinct answer. 0.97. What is the ratio of the Number of enrolments of both sexes of Liberia in 2008 to that in 2009?
Make the answer very short. 0.89. What is the ratio of the Number of enrolments of both sexes of Maldives in 2008 to that in 2009?
Make the answer very short. 1.05. What is the ratio of the Number of enrolments of both sexes in Least developed countries in 2008 to that in 2011?
Provide a succinct answer. 0.92. What is the ratio of the Number of enrolments of both sexes of Liberia in 2008 to that in 2011?
Offer a terse response. 0.8. What is the ratio of the Number of enrolments of both sexes of Maldives in 2008 to that in 2011?
Your answer should be very brief. 1.17. What is the ratio of the Number of enrolments of both sexes of Russian Federation in 2008 to that in 2011?
Make the answer very short. 0.93. What is the ratio of the Number of enrolments of both sexes of Least developed countries in 2009 to that in 2011?
Make the answer very short. 0.94. What is the ratio of the Number of enrolments of both sexes in Liberia in 2009 to that in 2011?
Ensure brevity in your answer.  0.9. What is the ratio of the Number of enrolments of both sexes in Maldives in 2009 to that in 2011?
Offer a terse response. 1.11. What is the ratio of the Number of enrolments of both sexes of Russian Federation in 2009 to that in 2011?
Make the answer very short. 0.94. What is the difference between the highest and the second highest Number of enrolments of both sexes of Least developed countries?
Ensure brevity in your answer.  7.83e+06. What is the difference between the highest and the second highest Number of enrolments of both sexes in Liberia?
Provide a succinct answer. 6.93e+04. What is the difference between the highest and the second highest Number of enrolments of both sexes of Maldives?
Offer a very short reply. 528. What is the difference between the highest and the second highest Number of enrolments of both sexes in Russian Federation?
Give a very brief answer. 6.04e+05. What is the difference between the highest and the lowest Number of enrolments of both sexes of Least developed countries?
Your response must be concise. 5.85e+07. What is the difference between the highest and the lowest Number of enrolments of both sexes in Liberia?
Offer a terse response. 2.79e+05. What is the difference between the highest and the lowest Number of enrolments of both sexes of Maldives?
Your answer should be compact. 3.38e+04. What is the difference between the highest and the lowest Number of enrolments of both sexes in Russian Federation?
Your answer should be very brief. 1.77e+06. 